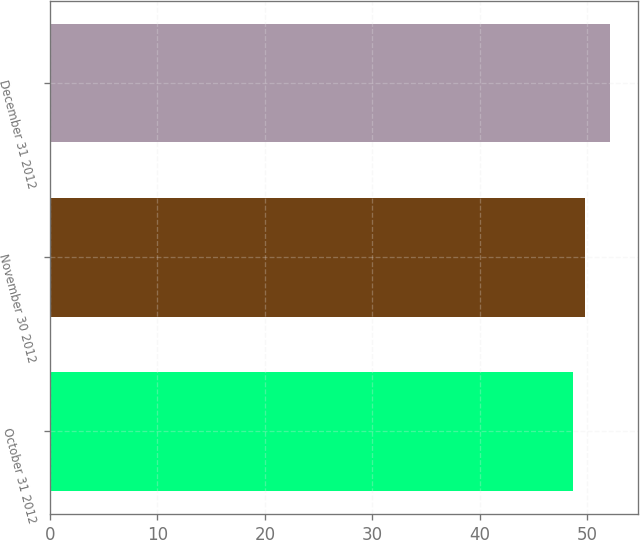<chart> <loc_0><loc_0><loc_500><loc_500><bar_chart><fcel>October 31 2012<fcel>November 30 2012<fcel>December 31 2012<nl><fcel>48.67<fcel>49.81<fcel>52.07<nl></chart> 